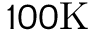Convert formula to latex. <formula><loc_0><loc_0><loc_500><loc_500>1 0 0 K</formula> 